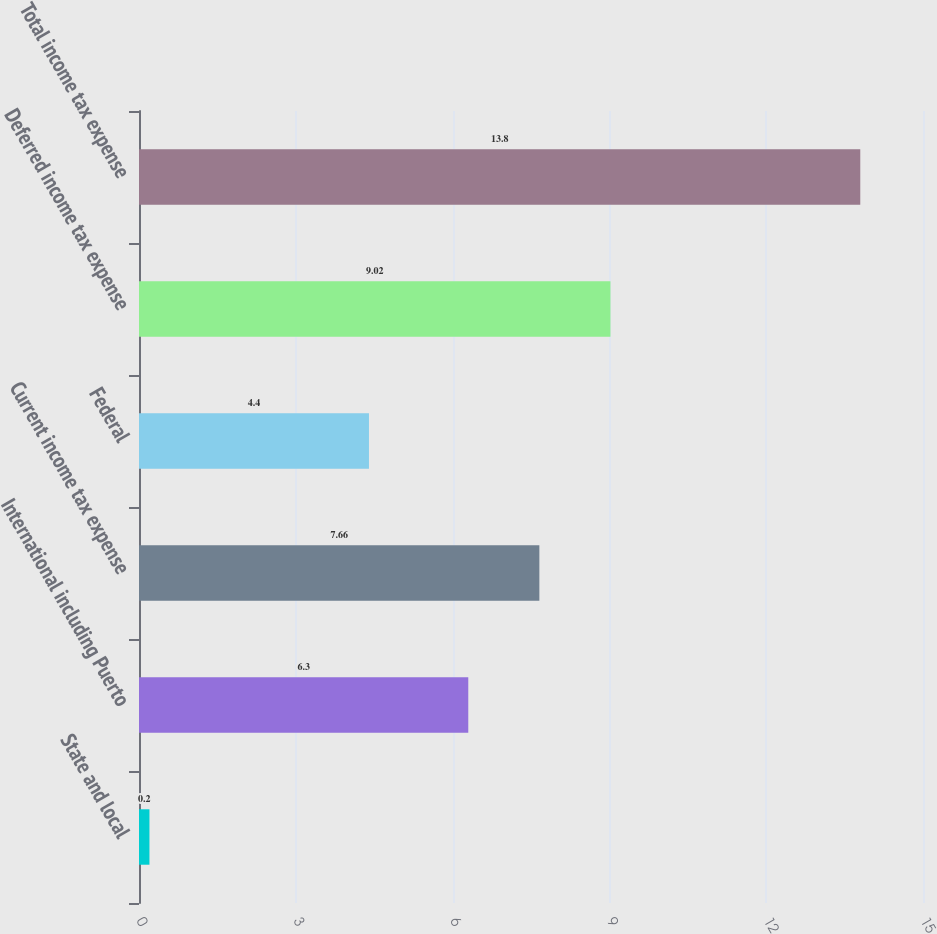<chart> <loc_0><loc_0><loc_500><loc_500><bar_chart><fcel>State and local<fcel>International including Puerto<fcel>Current income tax expense<fcel>Federal<fcel>Deferred income tax expense<fcel>Total income tax expense<nl><fcel>0.2<fcel>6.3<fcel>7.66<fcel>4.4<fcel>9.02<fcel>13.8<nl></chart> 